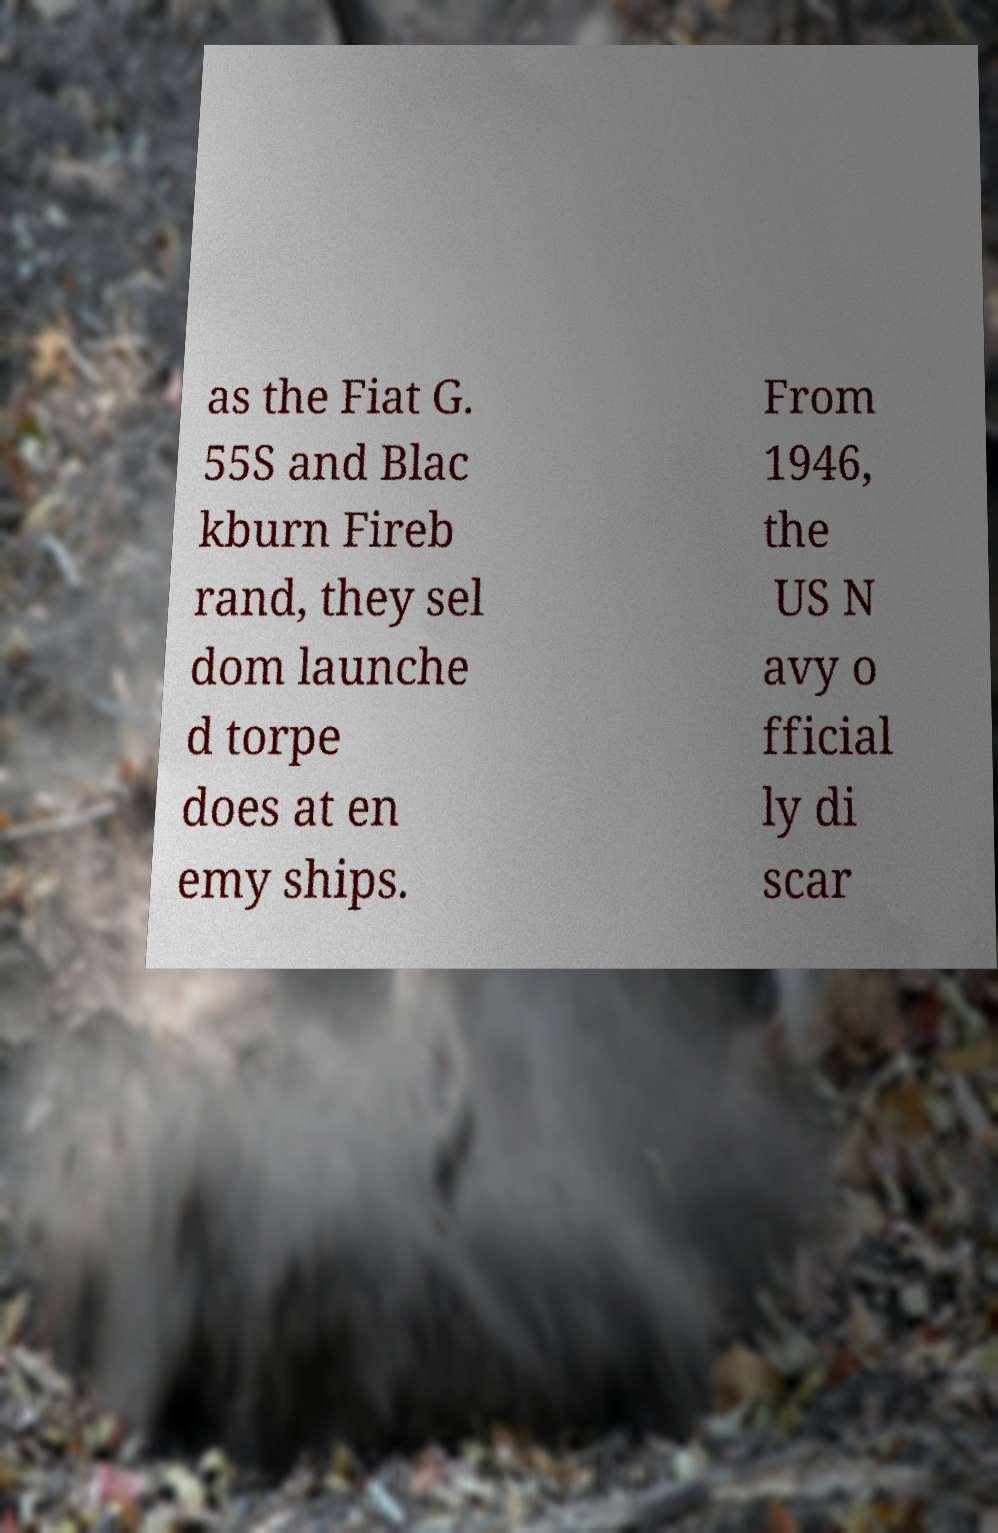Please identify and transcribe the text found in this image. as the Fiat G. 55S and Blac kburn Fireb rand, they sel dom launche d torpe does at en emy ships. From 1946, the US N avy o fficial ly di scar 